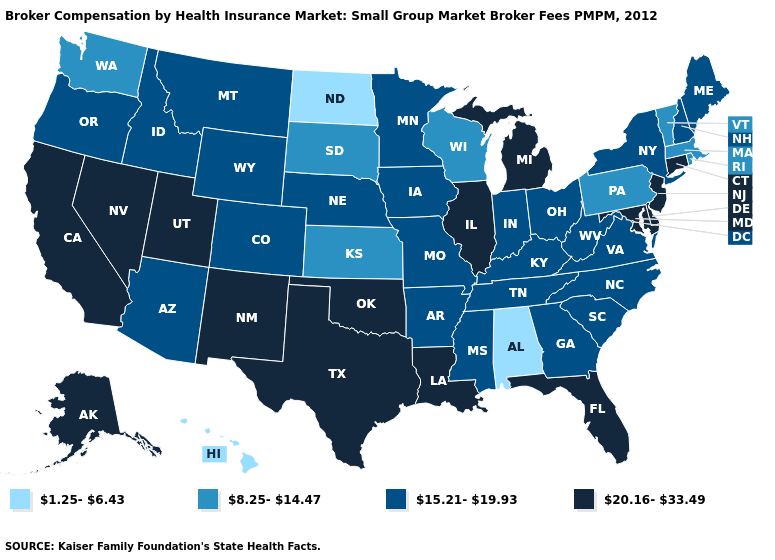Name the states that have a value in the range 8.25-14.47?
Keep it brief. Kansas, Massachusetts, Pennsylvania, Rhode Island, South Dakota, Vermont, Washington, Wisconsin. What is the value of Georgia?
Answer briefly. 15.21-19.93. Name the states that have a value in the range 20.16-33.49?
Be succinct. Alaska, California, Connecticut, Delaware, Florida, Illinois, Louisiana, Maryland, Michigan, Nevada, New Jersey, New Mexico, Oklahoma, Texas, Utah. What is the value of Oregon?
Concise answer only. 15.21-19.93. What is the highest value in the Northeast ?
Quick response, please. 20.16-33.49. Does Oklahoma have the highest value in the South?
Be succinct. Yes. What is the value of New Hampshire?
Be succinct. 15.21-19.93. Name the states that have a value in the range 8.25-14.47?
Keep it brief. Kansas, Massachusetts, Pennsylvania, Rhode Island, South Dakota, Vermont, Washington, Wisconsin. Does Massachusetts have a higher value than Kansas?
Short answer required. No. What is the value of New Jersey?
Be succinct. 20.16-33.49. Name the states that have a value in the range 8.25-14.47?
Write a very short answer. Kansas, Massachusetts, Pennsylvania, Rhode Island, South Dakota, Vermont, Washington, Wisconsin. Does the map have missing data?
Give a very brief answer. No. Does Virginia have the highest value in the USA?
Concise answer only. No. What is the lowest value in the West?
Short answer required. 1.25-6.43. What is the value of Tennessee?
Short answer required. 15.21-19.93. 